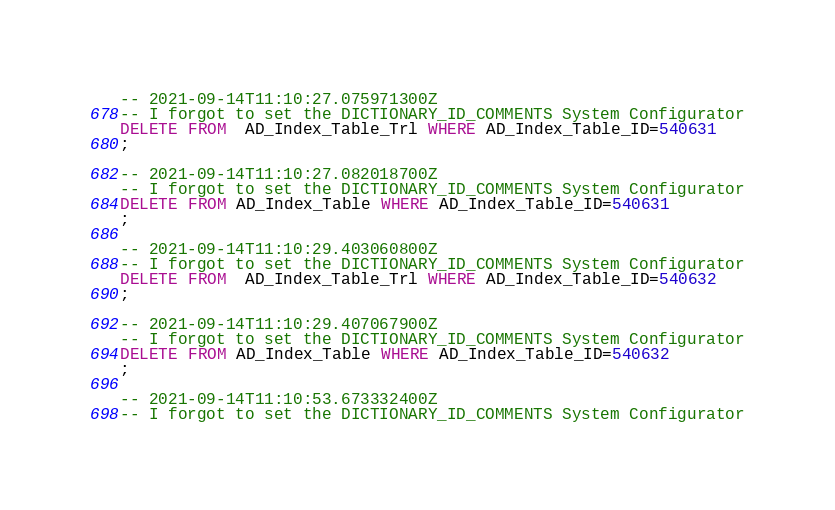Convert code to text. <code><loc_0><loc_0><loc_500><loc_500><_SQL_>-- 2021-09-14T11:10:27.075971300Z
-- I forgot to set the DICTIONARY_ID_COMMENTS System Configurator
DELETE FROM  AD_Index_Table_Trl WHERE AD_Index_Table_ID=540631
;

-- 2021-09-14T11:10:27.082018700Z
-- I forgot to set the DICTIONARY_ID_COMMENTS System Configurator
DELETE FROM AD_Index_Table WHERE AD_Index_Table_ID=540631
;

-- 2021-09-14T11:10:29.403060800Z
-- I forgot to set the DICTIONARY_ID_COMMENTS System Configurator
DELETE FROM  AD_Index_Table_Trl WHERE AD_Index_Table_ID=540632
;

-- 2021-09-14T11:10:29.407067900Z
-- I forgot to set the DICTIONARY_ID_COMMENTS System Configurator
DELETE FROM AD_Index_Table WHERE AD_Index_Table_ID=540632
;

-- 2021-09-14T11:10:53.673332400Z
-- I forgot to set the DICTIONARY_ID_COMMENTS System Configurator</code> 